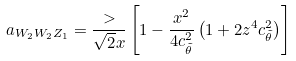Convert formula to latex. <formula><loc_0><loc_0><loc_500><loc_500>a _ { W _ { 2 } W _ { 2 } Z _ { 1 } } = \frac { > } { \sqrt { 2 } x } \left [ 1 - \frac { x ^ { 2 } } { 4 c ^ { 2 } _ { \tilde { \theta } } } \left ( 1 + 2 z ^ { 4 } c ^ { 2 } _ { \tilde { \theta } } \right ) \right ]</formula> 